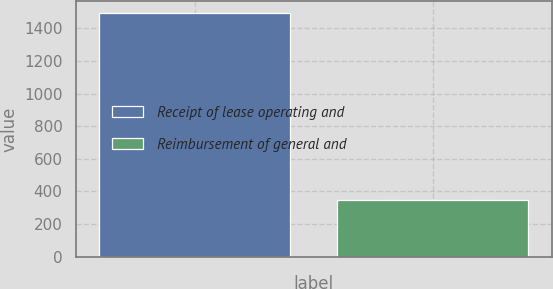<chart> <loc_0><loc_0><loc_500><loc_500><bar_chart><fcel>Receipt of lease operating and<fcel>Reimbursement of general and<nl><fcel>1493<fcel>348<nl></chart> 